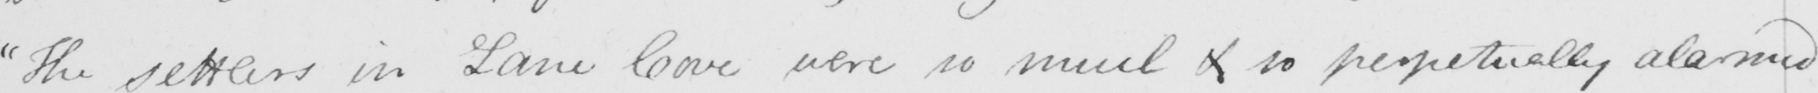Can you read and transcribe this handwriting? " The settlers in Lane Cove were so much  <gap/>  so perpetually alarmed 